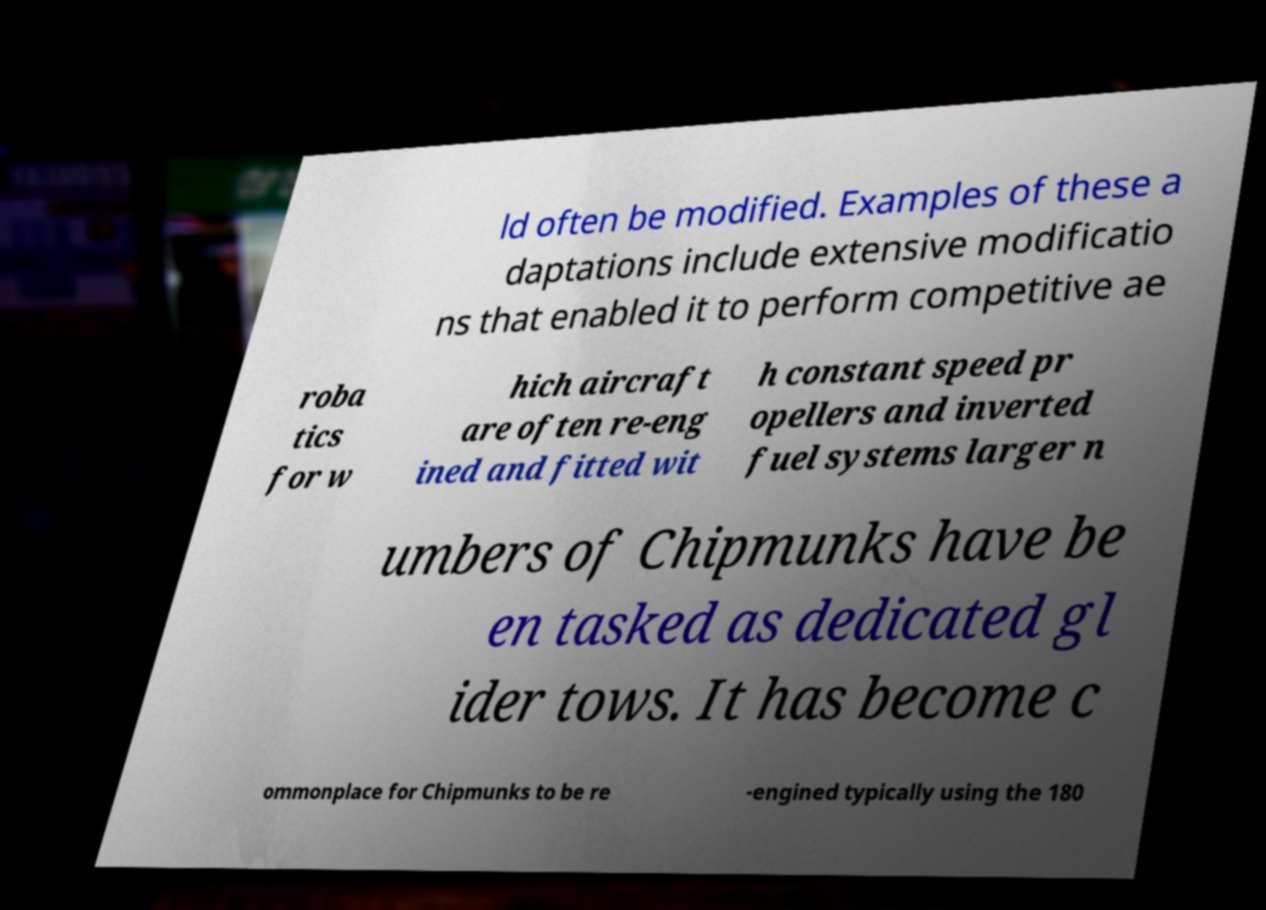Could you extract and type out the text from this image? ld often be modified. Examples of these a daptations include extensive modificatio ns that enabled it to perform competitive ae roba tics for w hich aircraft are often re-eng ined and fitted wit h constant speed pr opellers and inverted fuel systems larger n umbers of Chipmunks have be en tasked as dedicated gl ider tows. It has become c ommonplace for Chipmunks to be re -engined typically using the 180 